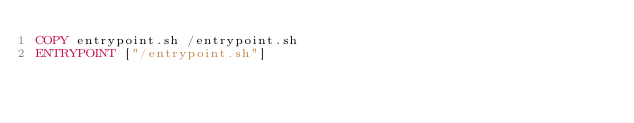<code> <loc_0><loc_0><loc_500><loc_500><_Dockerfile_>COPY entrypoint.sh /entrypoint.sh
ENTRYPOINT ["/entrypoint.sh"]
</code> 